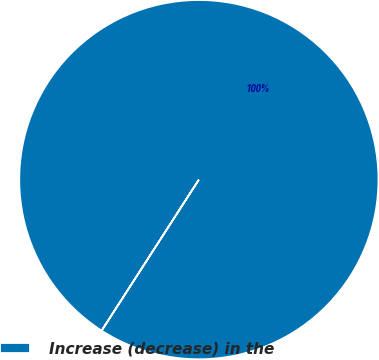Convert chart. <chart><loc_0><loc_0><loc_500><loc_500><pie_chart><fcel>Increase (decrease) in the<nl><fcel>100.0%<nl></chart> 